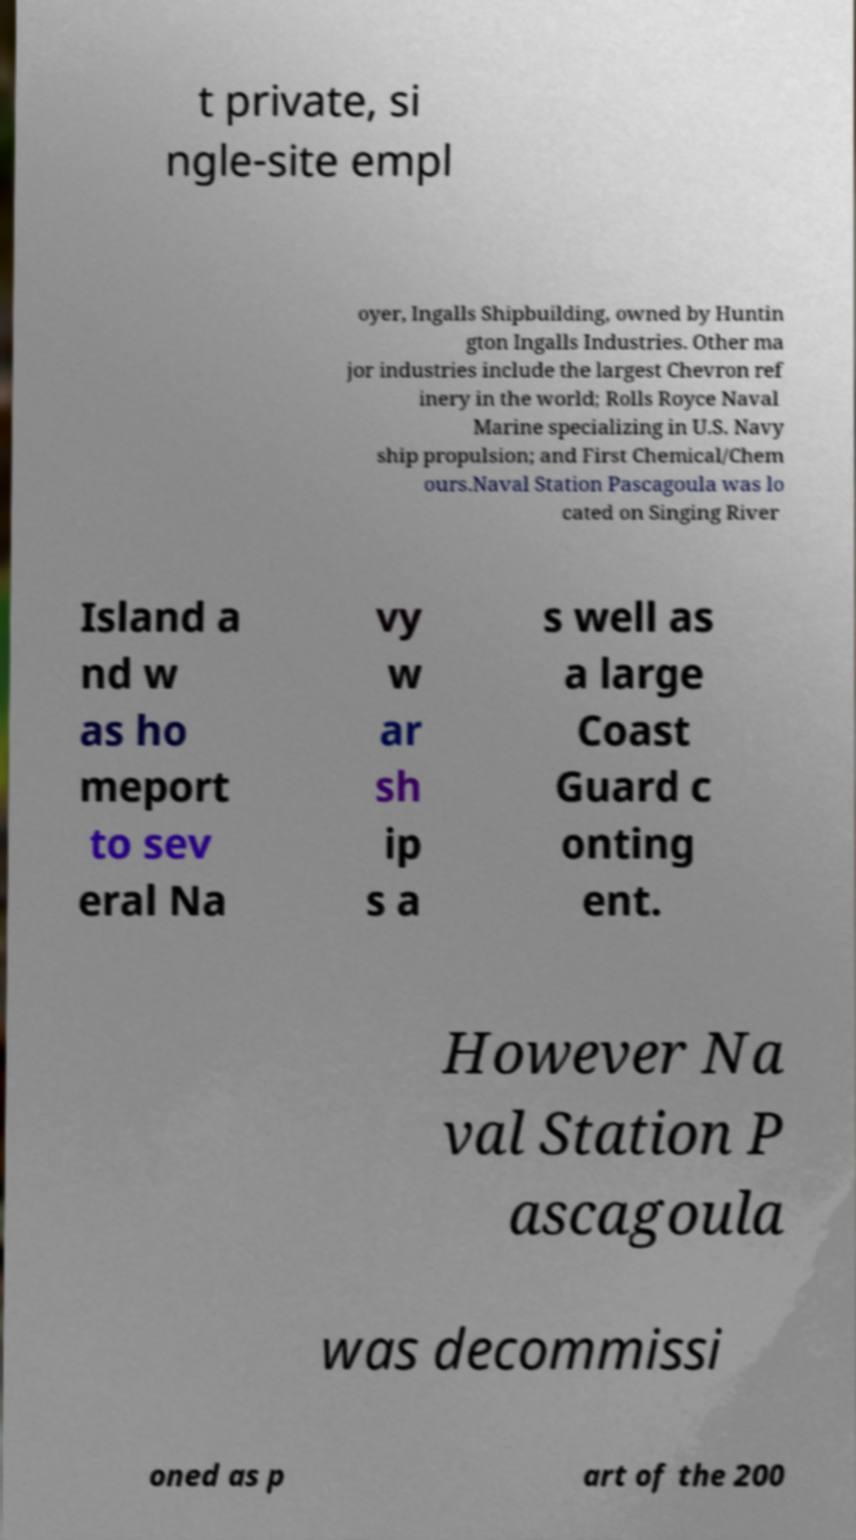Could you extract and type out the text from this image? t private, si ngle-site empl oyer, Ingalls Shipbuilding, owned by Huntin gton Ingalls Industries. Other ma jor industries include the largest Chevron ref inery in the world; Rolls Royce Naval Marine specializing in U.S. Navy ship propulsion; and First Chemical/Chem ours.Naval Station Pascagoula was lo cated on Singing River Island a nd w as ho meport to sev eral Na vy w ar sh ip s a s well as a large Coast Guard c onting ent. However Na val Station P ascagoula was decommissi oned as p art of the 200 